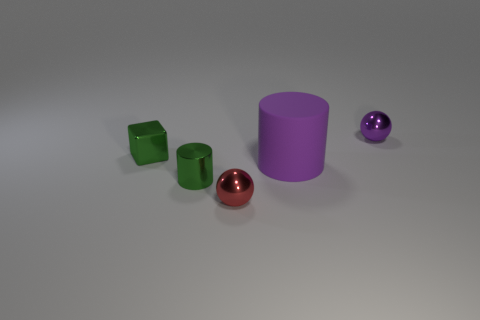Add 4 spheres. How many objects exist? 9 Subtract all cylinders. How many objects are left? 3 Subtract all blue objects. Subtract all purple objects. How many objects are left? 3 Add 4 shiny things. How many shiny things are left? 8 Add 3 rubber cylinders. How many rubber cylinders exist? 4 Subtract 0 brown cylinders. How many objects are left? 5 